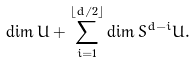Convert formula to latex. <formula><loc_0><loc_0><loc_500><loc_500>\dim U + \sum _ { i = 1 } ^ { \lfloor d / 2 \rfloor } \dim S ^ { d - i } U .</formula> 